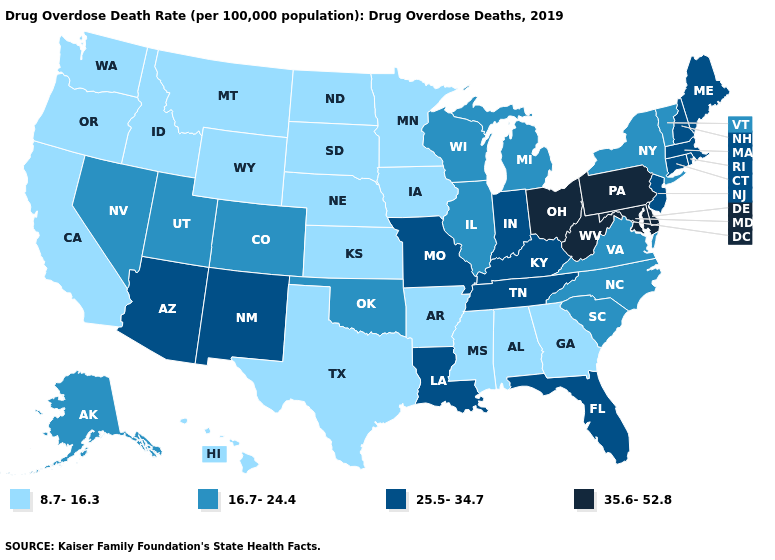How many symbols are there in the legend?
Be succinct. 4. Among the states that border South Dakota , which have the lowest value?
Answer briefly. Iowa, Minnesota, Montana, Nebraska, North Dakota, Wyoming. Does Arizona have the highest value in the West?
Answer briefly. Yes. What is the value of Vermont?
Quick response, please. 16.7-24.4. What is the value of Maryland?
Write a very short answer. 35.6-52.8. What is the value of Tennessee?
Short answer required. 25.5-34.7. Among the states that border Washington , which have the highest value?
Short answer required. Idaho, Oregon. Name the states that have a value in the range 35.6-52.8?
Concise answer only. Delaware, Maryland, Ohio, Pennsylvania, West Virginia. Name the states that have a value in the range 25.5-34.7?
Be succinct. Arizona, Connecticut, Florida, Indiana, Kentucky, Louisiana, Maine, Massachusetts, Missouri, New Hampshire, New Jersey, New Mexico, Rhode Island, Tennessee. Which states have the lowest value in the South?
Answer briefly. Alabama, Arkansas, Georgia, Mississippi, Texas. What is the value of Michigan?
Be succinct. 16.7-24.4. Name the states that have a value in the range 35.6-52.8?
Short answer required. Delaware, Maryland, Ohio, Pennsylvania, West Virginia. Name the states that have a value in the range 8.7-16.3?
Short answer required. Alabama, Arkansas, California, Georgia, Hawaii, Idaho, Iowa, Kansas, Minnesota, Mississippi, Montana, Nebraska, North Dakota, Oregon, South Dakota, Texas, Washington, Wyoming. What is the value of Massachusetts?
Keep it brief. 25.5-34.7. Name the states that have a value in the range 25.5-34.7?
Quick response, please. Arizona, Connecticut, Florida, Indiana, Kentucky, Louisiana, Maine, Massachusetts, Missouri, New Hampshire, New Jersey, New Mexico, Rhode Island, Tennessee. 